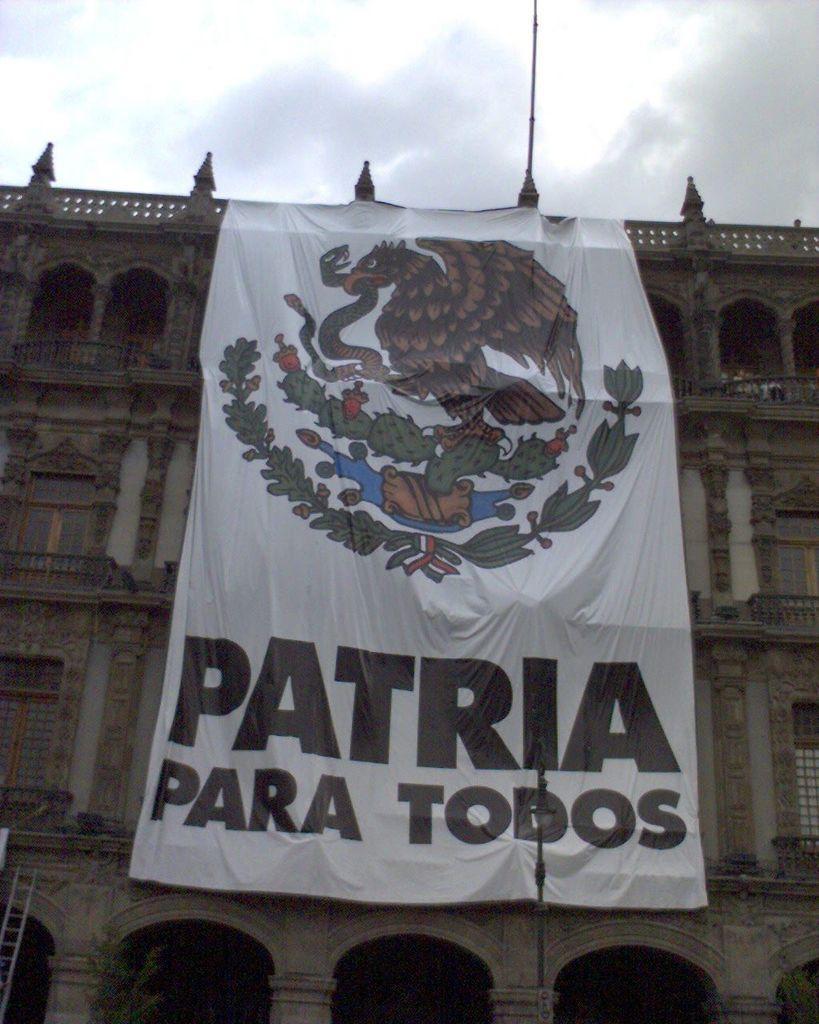Could you give a brief overview of what you see in this image? In this image, we can see a building and there is a banner with some text and some pictures and there is a ladder. At the top, there are clouds in the sky. 